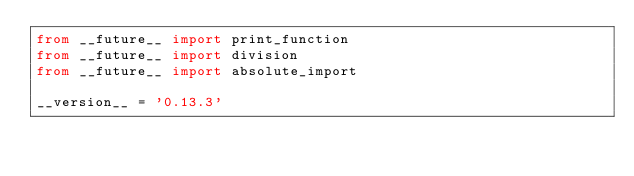Convert code to text. <code><loc_0><loc_0><loc_500><loc_500><_Python_>from __future__ import print_function
from __future__ import division
from __future__ import absolute_import

__version__ = '0.13.3'
</code> 